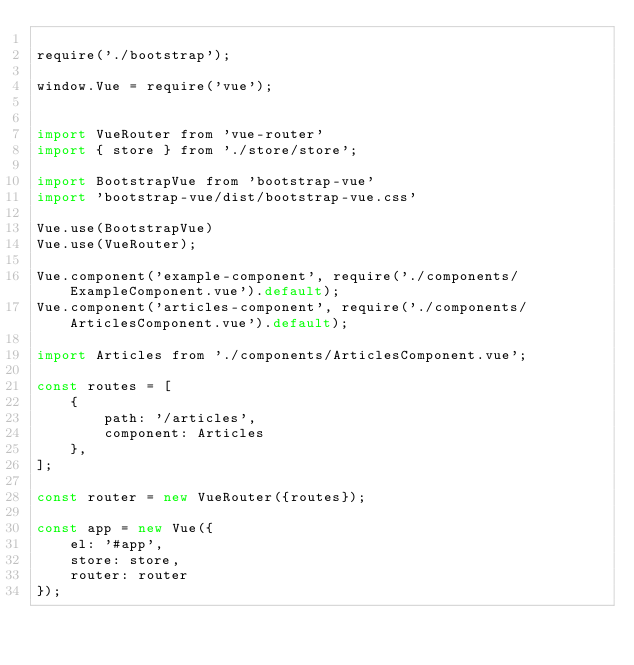<code> <loc_0><loc_0><loc_500><loc_500><_JavaScript_>
require('./bootstrap');

window.Vue = require('vue');


import VueRouter from 'vue-router'
import { store } from './store/store';

import BootstrapVue from 'bootstrap-vue'
import 'bootstrap-vue/dist/bootstrap-vue.css'

Vue.use(BootstrapVue)
Vue.use(VueRouter);

Vue.component('example-component', require('./components/ExampleComponent.vue').default);
Vue.component('articles-component', require('./components/ArticlesComponent.vue').default);

import Articles from './components/ArticlesComponent.vue';

const routes = [
    {
        path: '/articles',
        component: Articles
    },
];

const router = new VueRouter({routes});

const app = new Vue({
    el: '#app',
    store: store,
    router: router
});
</code> 